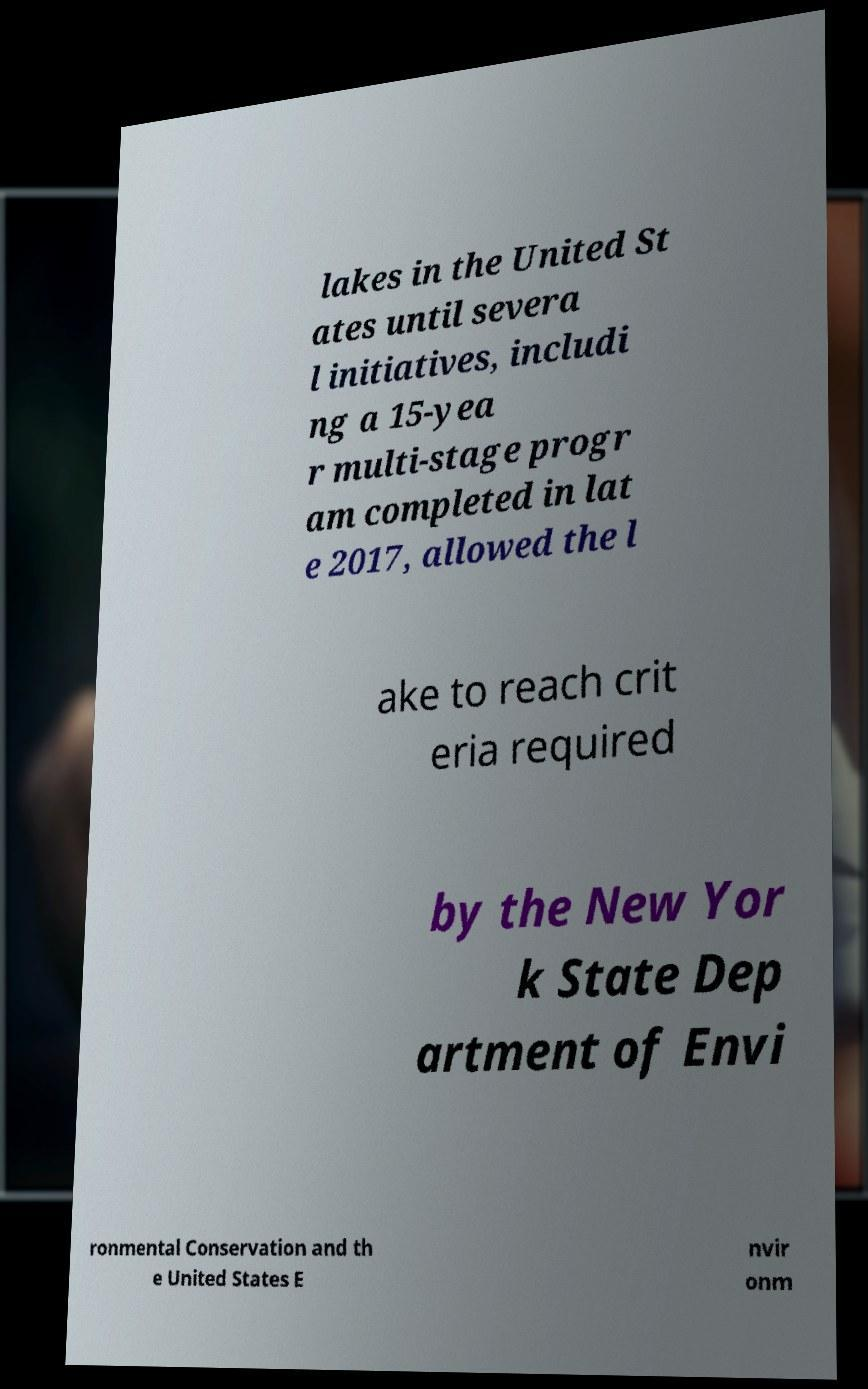What messages or text are displayed in this image? I need them in a readable, typed format. lakes in the United St ates until severa l initiatives, includi ng a 15-yea r multi-stage progr am completed in lat e 2017, allowed the l ake to reach crit eria required by the New Yor k State Dep artment of Envi ronmental Conservation and th e United States E nvir onm 